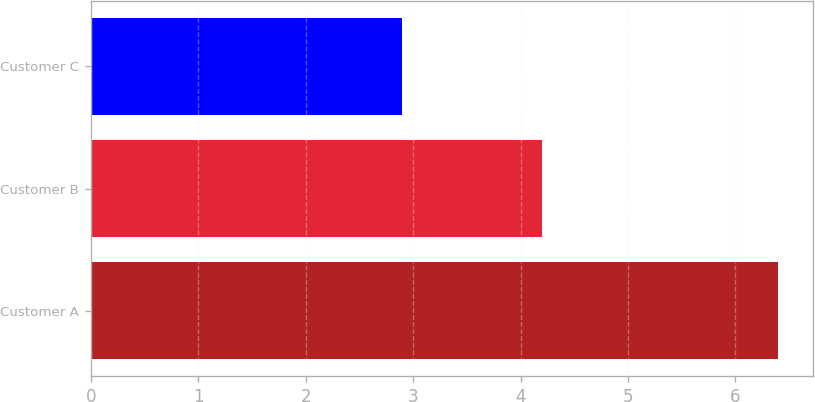Convert chart to OTSL. <chart><loc_0><loc_0><loc_500><loc_500><bar_chart><fcel>Customer A<fcel>Customer B<fcel>Customer C<nl><fcel>6.4<fcel>4.2<fcel>2.9<nl></chart> 